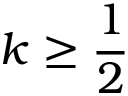<formula> <loc_0><loc_0><loc_500><loc_500>k \geq \frac { 1 } { 2 }</formula> 